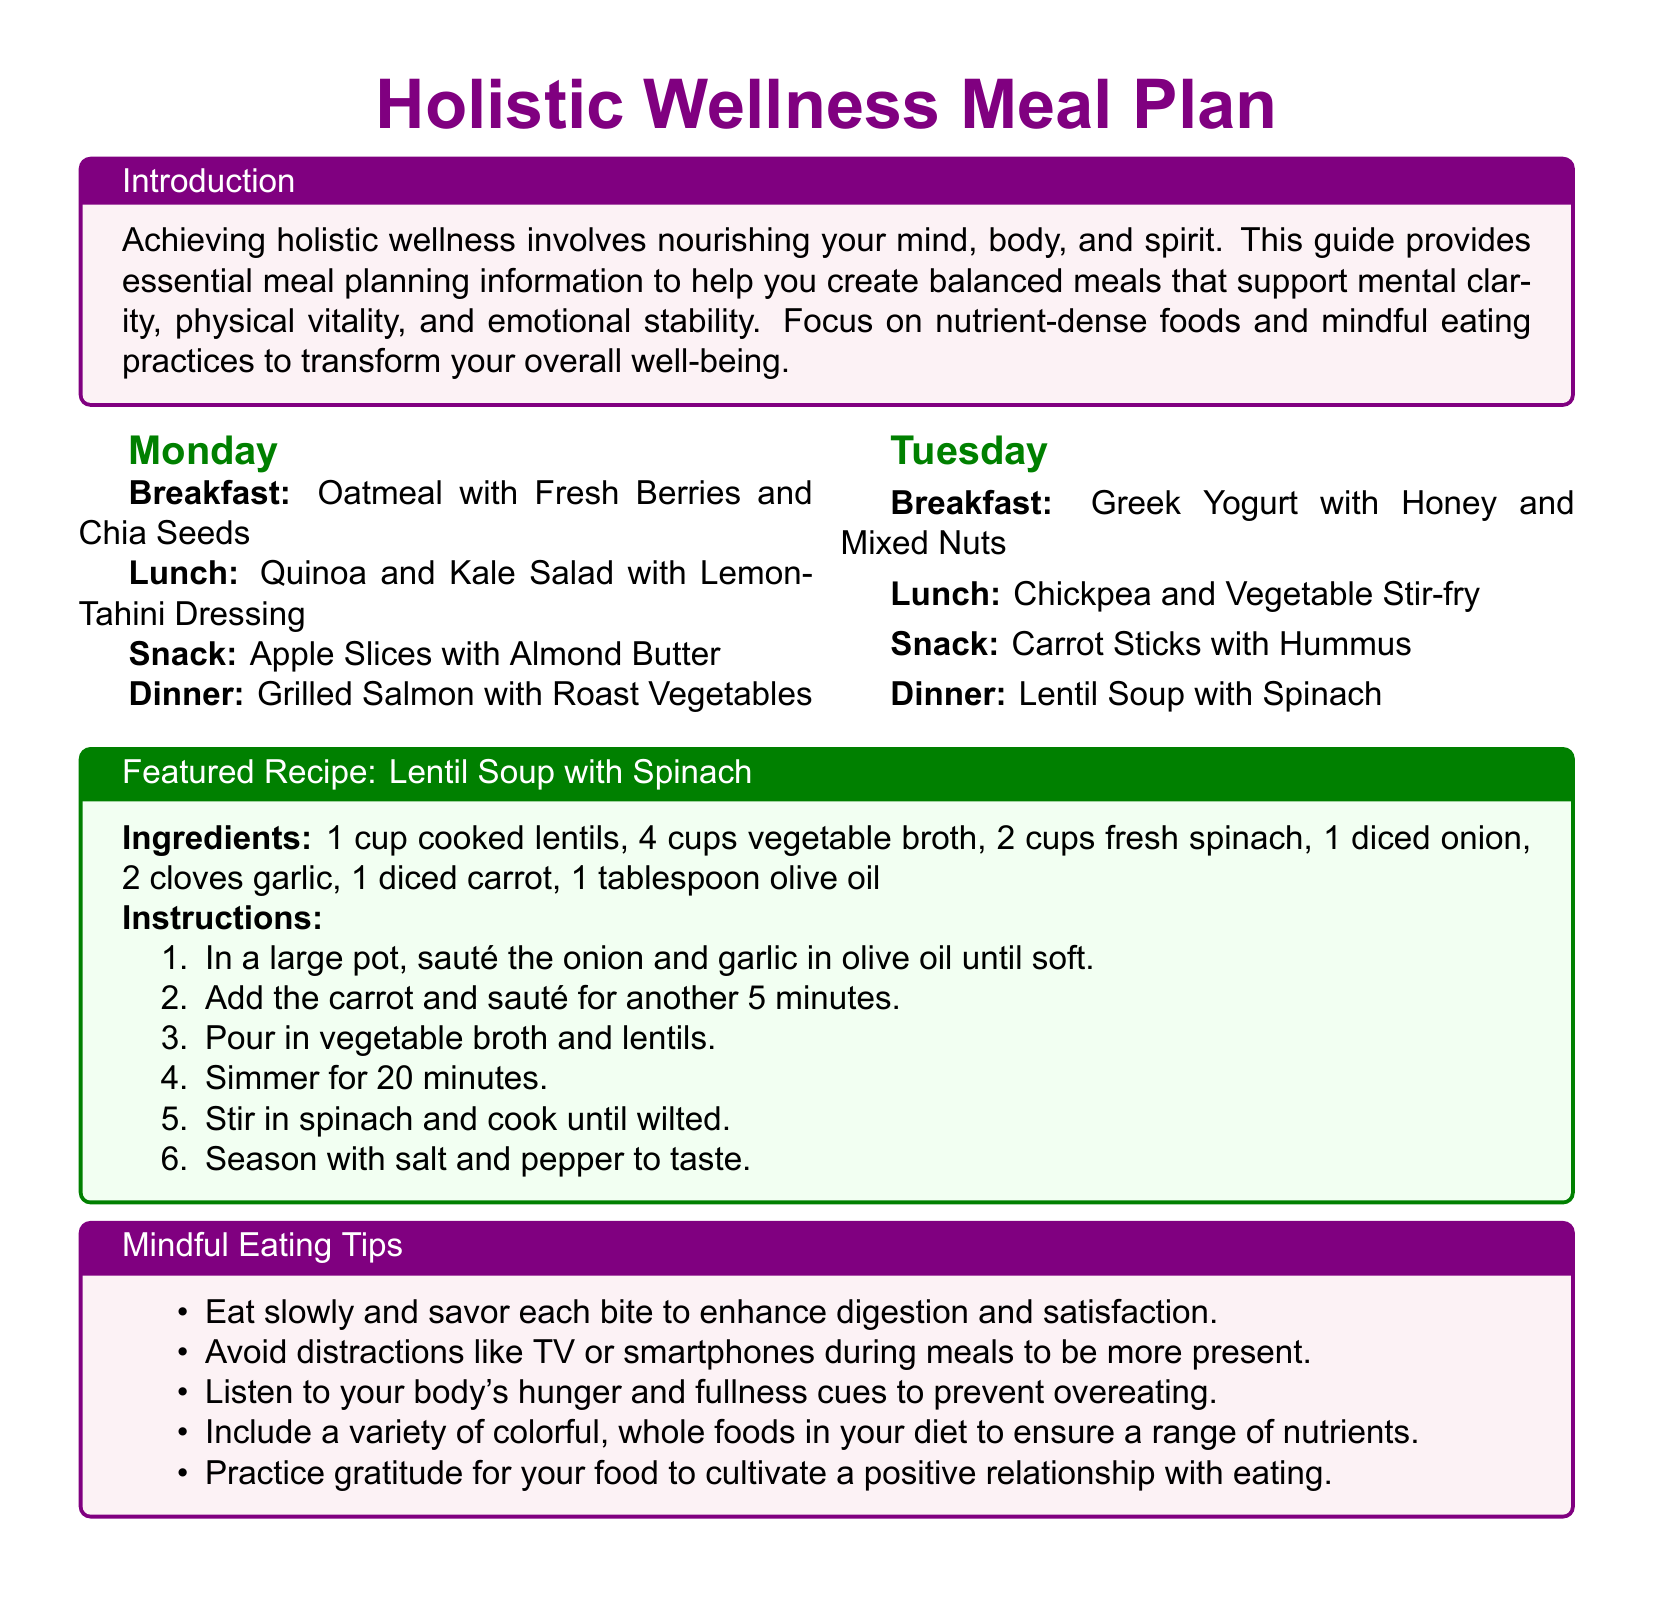What is the title of the meal plan? The title is prominently featured at the top of the document.
Answer: Holistic Wellness Meal Plan What day of the week features the Quinoa and Kale Salad? The meal plan includes specific menus for each day of the week.
Answer: Monday What is included in the featured recipe? The featured recipe box lists ingredients and instructions.
Answer: Lentil Soup with Spinach How many cups of vegetable broth are needed for the Lentil Soup? The recipe outlines the specific quantities required for each ingredient.
Answer: 4 cups What should you do to enhance digestion according to the Mindful Eating Tips? The Mindful Eating Tips provide strategies for improving the meal experience.
Answer: Eat slowly How is emotional stability supported in the meal plan? The document provides an overview of how meals affect different aspects of wellness.
Answer: Nutrient-dense foods What kind of dressing is used for the Quinoa and Kale Salad? The meal plan specifies details about the Salad.
Answer: Lemon-Tahini Dressing What is a suggested snack for Tuesday? The meal plan outlines snacks for each day.
Answer: Carrot Sticks with Hummus 